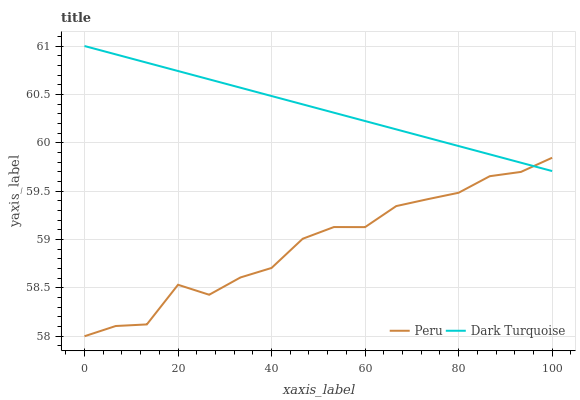Does Peru have the minimum area under the curve?
Answer yes or no. Yes. Does Dark Turquoise have the maximum area under the curve?
Answer yes or no. Yes. Does Peru have the maximum area under the curve?
Answer yes or no. No. Is Dark Turquoise the smoothest?
Answer yes or no. Yes. Is Peru the roughest?
Answer yes or no. Yes. Is Peru the smoothest?
Answer yes or no. No. Does Peru have the lowest value?
Answer yes or no. Yes. Does Dark Turquoise have the highest value?
Answer yes or no. Yes. Does Peru have the highest value?
Answer yes or no. No. Does Peru intersect Dark Turquoise?
Answer yes or no. Yes. Is Peru less than Dark Turquoise?
Answer yes or no. No. Is Peru greater than Dark Turquoise?
Answer yes or no. No. 